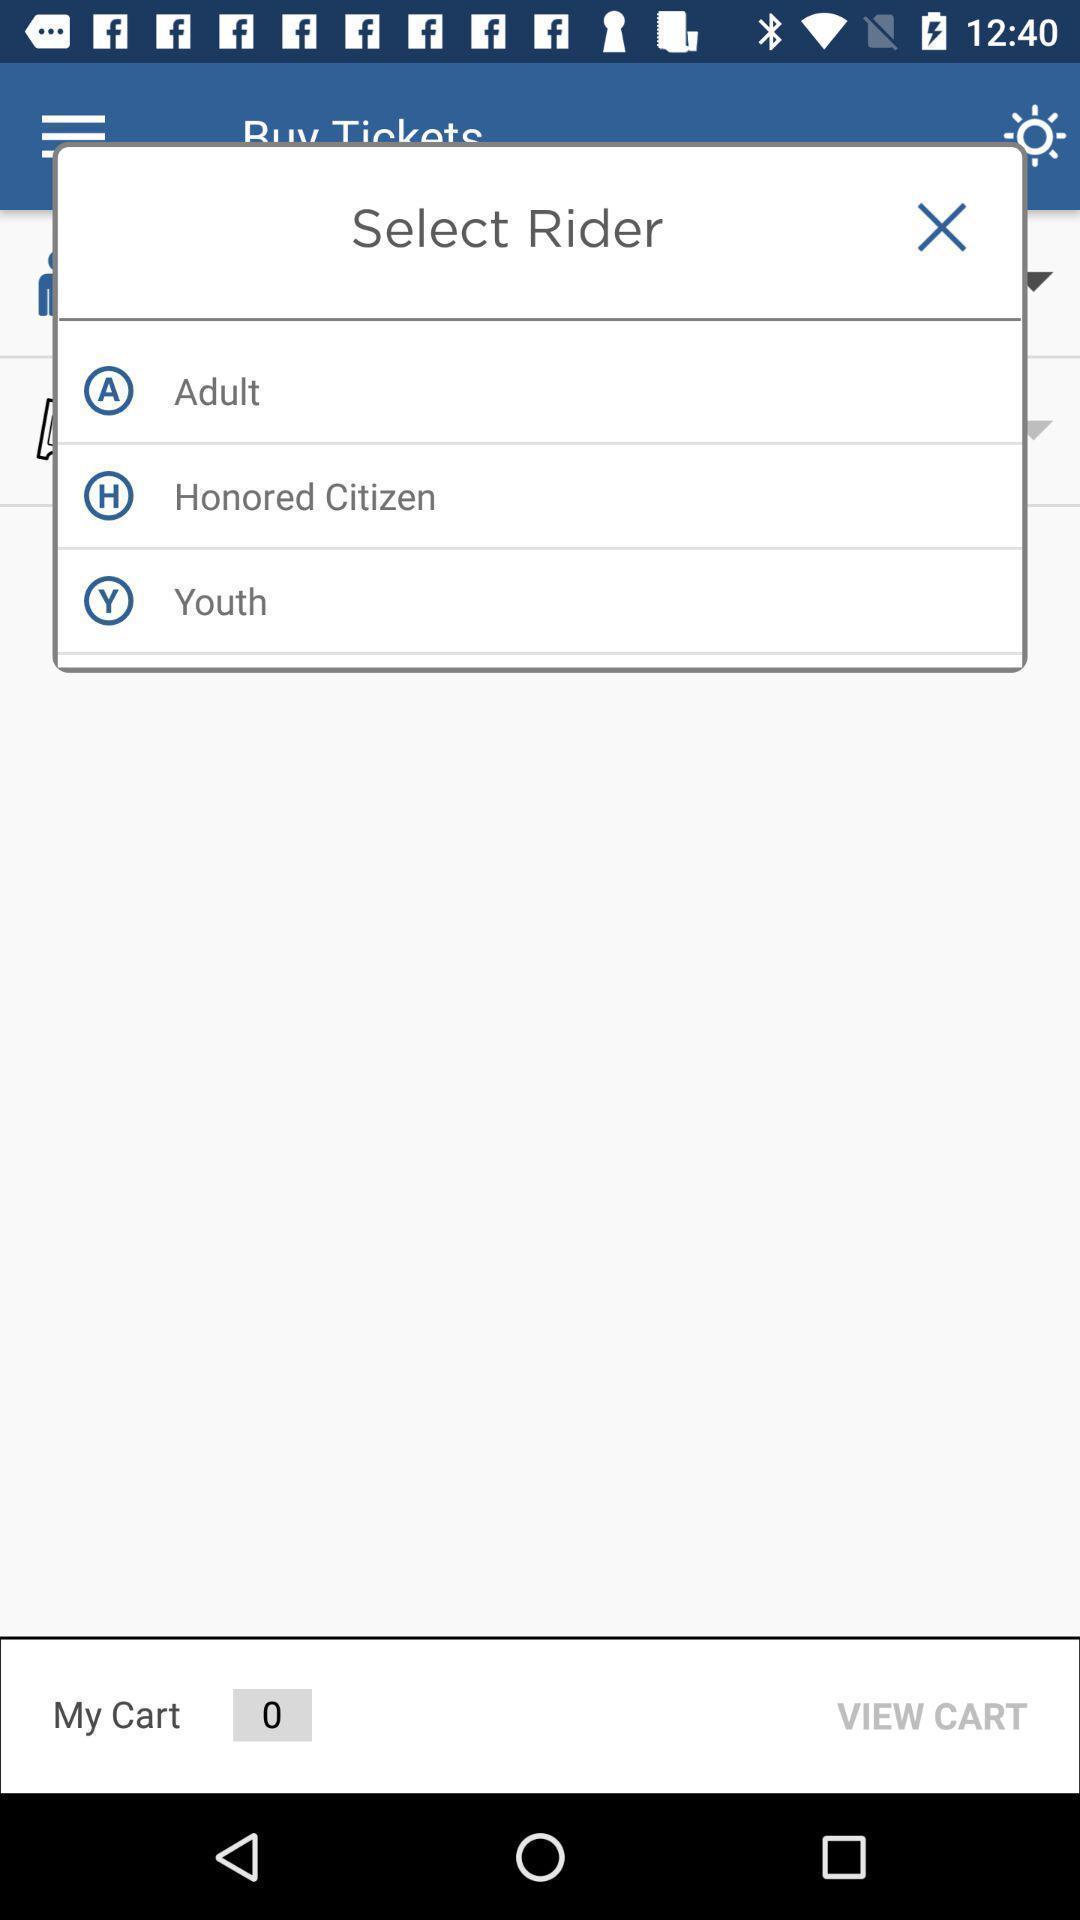Please provide a description for this image. Pop-up showing select gender. 